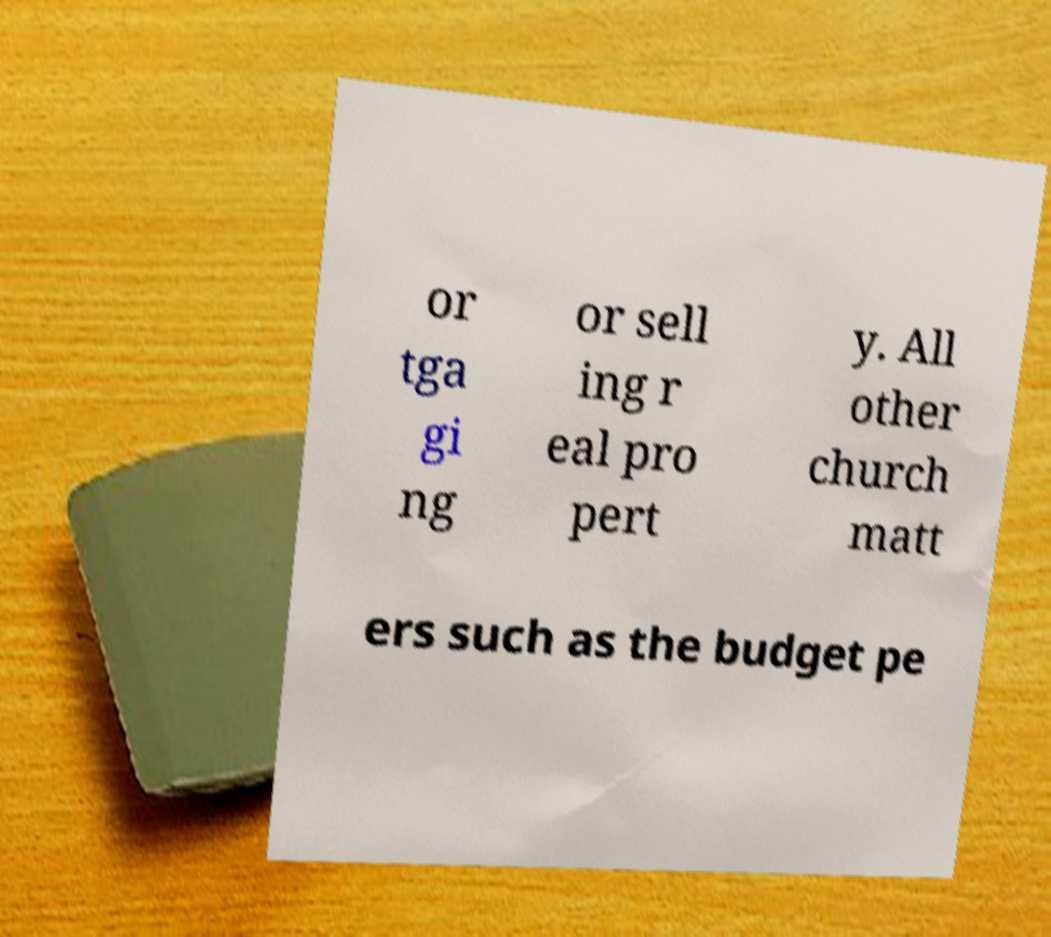There's text embedded in this image that I need extracted. Can you transcribe it verbatim? or tga gi ng or sell ing r eal pro pert y. All other church matt ers such as the budget pe 